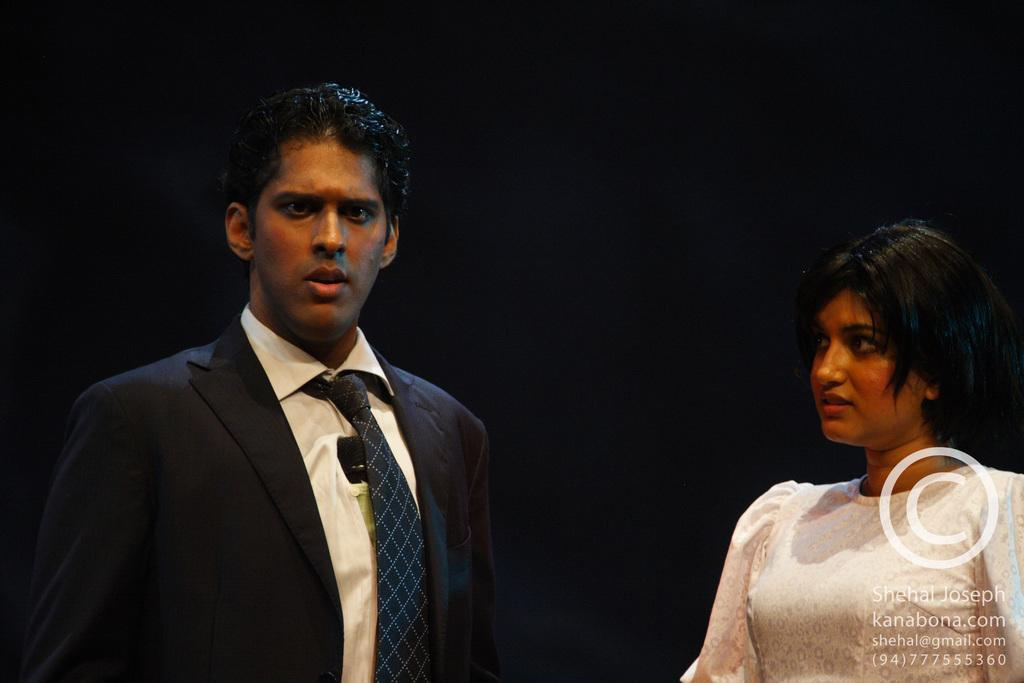How many people are in the image? There are two persons in the image. What is written or displayed at the bottom of the image? There is text at the bottom of the image. What can be observed about the background of the image? The background of the image is dark. What type of pies are being exchanged during the protest in the image? There is no protest or exchange of pies present in the image; it features two persons and text at the bottom with a dark background. 